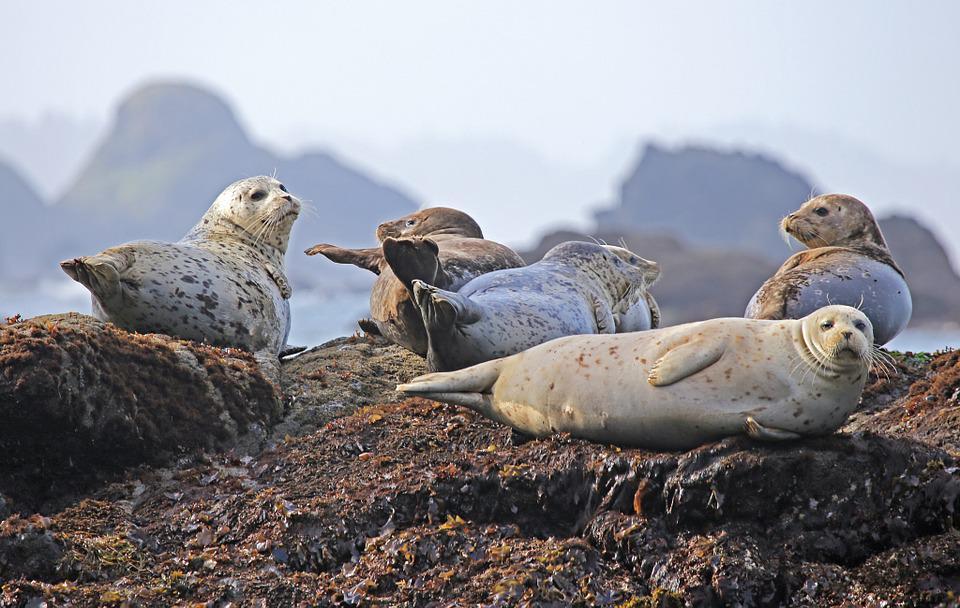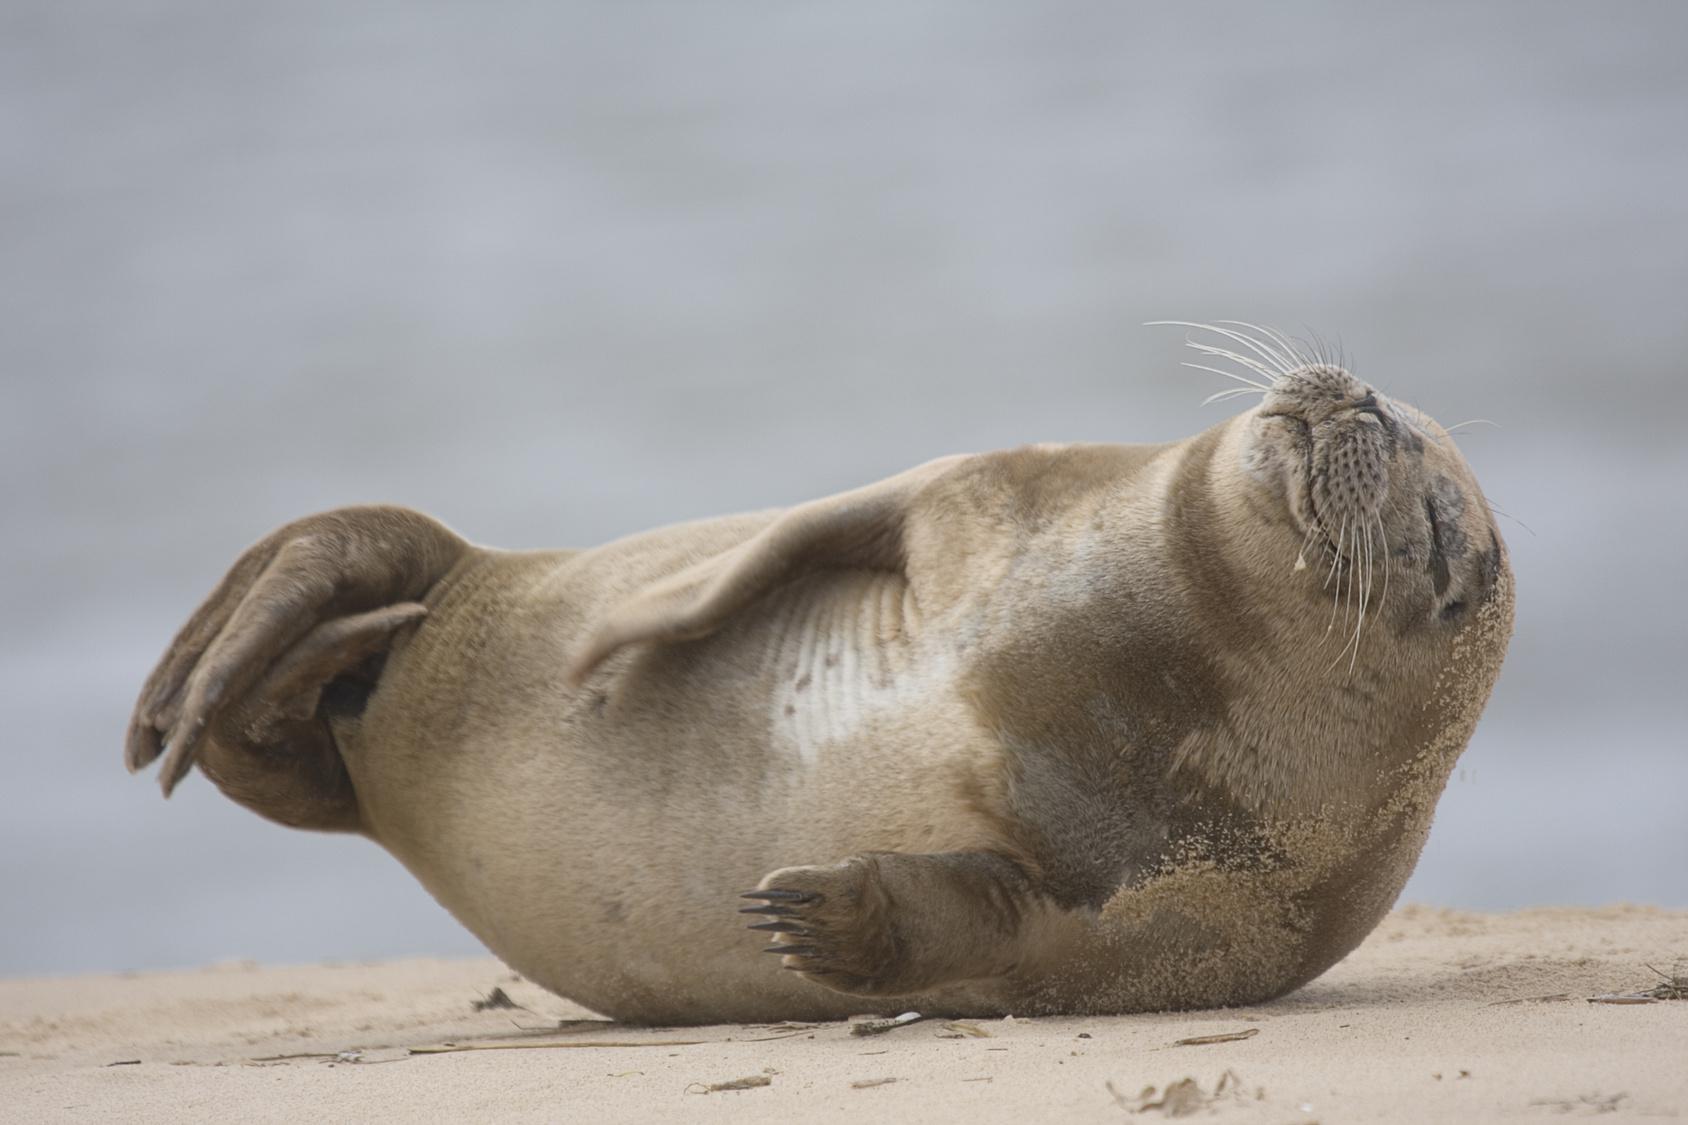The first image is the image on the left, the second image is the image on the right. Considering the images on both sides, is "There are no more than four animals." valid? Answer yes or no. No. The first image is the image on the left, the second image is the image on the right. Considering the images on both sides, is "A juvenile sea lion can be seen near an adult sea lion." valid? Answer yes or no. No. 